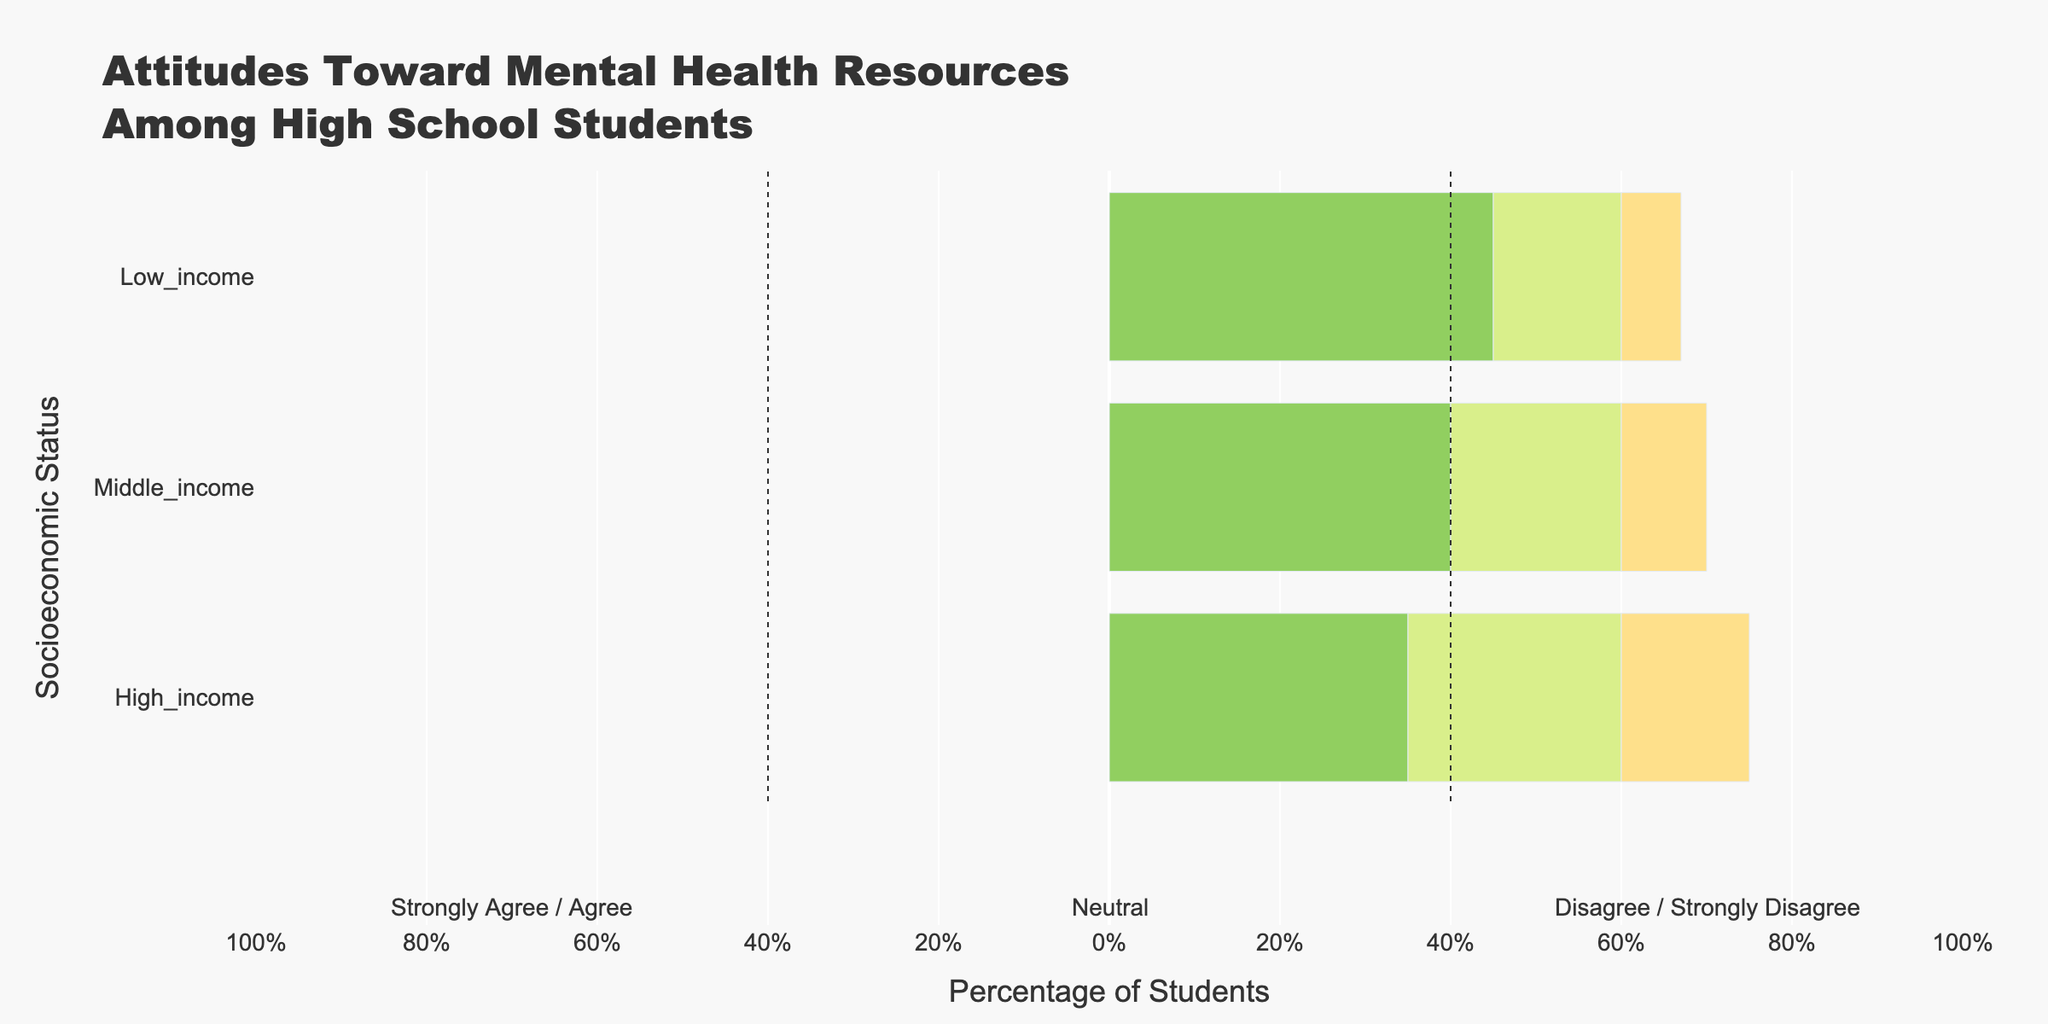How many students strongly agree and agree combined in the low-income group? Add the number of students who strongly agree (30) and agree (45) in the low-income group. So, 30 + 45 = 75
Answer: 75 Which socioeconomic group has the highest proportion of students who strongly agree with mental health resources? The low-income group has 30% strongly agree, middle-income has 25%, and high-income has 20%. The highest proportion is in the low-income group.
Answer: Low-income How do the neutral responses compare between the income groups? Compare the percentage of neutral responses: low-income (15%), middle-income (20%), and high-income (25%). The high-income group has the highest, followed by middle-income, and then low-income.
Answer: High-income > Middle-income > Low-income What is the combined percentage of students who disagree and strongly disagree in the middle-income group? Add the percentage of students who disagree (10%) and strongly disagree (5%) in the middle-income group. So, 10 + 5 = 15%
Answer: 15% Which socioeconomic group has the smallest difference between strongly agree and strongly disagree percentages? Calculate the differences: low-income (30 - 3 = 27), middle-income (25 - 5 = 20), and high-income (20 - 5 = 15). The smallest difference is in the high-income group.
Answer: High-income Between which socioeconomic groups is the contrast in neutral responses the most significant? The difference in neutral responses between low-income and middle-income is 5% (20 - 15), low-income and high-income is 10% (25 - 15), middle-income and high-income is 5% (25 - 20). The most significant contrast is between low and high-income groups.
Answer: Low-income and High-income What is the ratio of students who disagree to those who agree in the high-income group? The number of students who disagree (15) and agree (35) in the high-income group is given. The ratio is 15:35, which simplifies to 3:7.
Answer: 3:7 How do the proportions of students who strongly disagree compare across all socioeconomic statuses? Compare the percentages: low-income (3%), middle-income (5%), and high-income (5%). Middle-income and high-income have the same proportion, which is higher than the low-income.
Answer: Middle-income = High-income > Low-income What is the difference in the proportion of students who agree between the low and middle-income groups? The proportion of students who agree in the low-income group is 45% and in the middle-income group is 40%. The difference is 45 - 40 = 5%.
Answer: 5% 